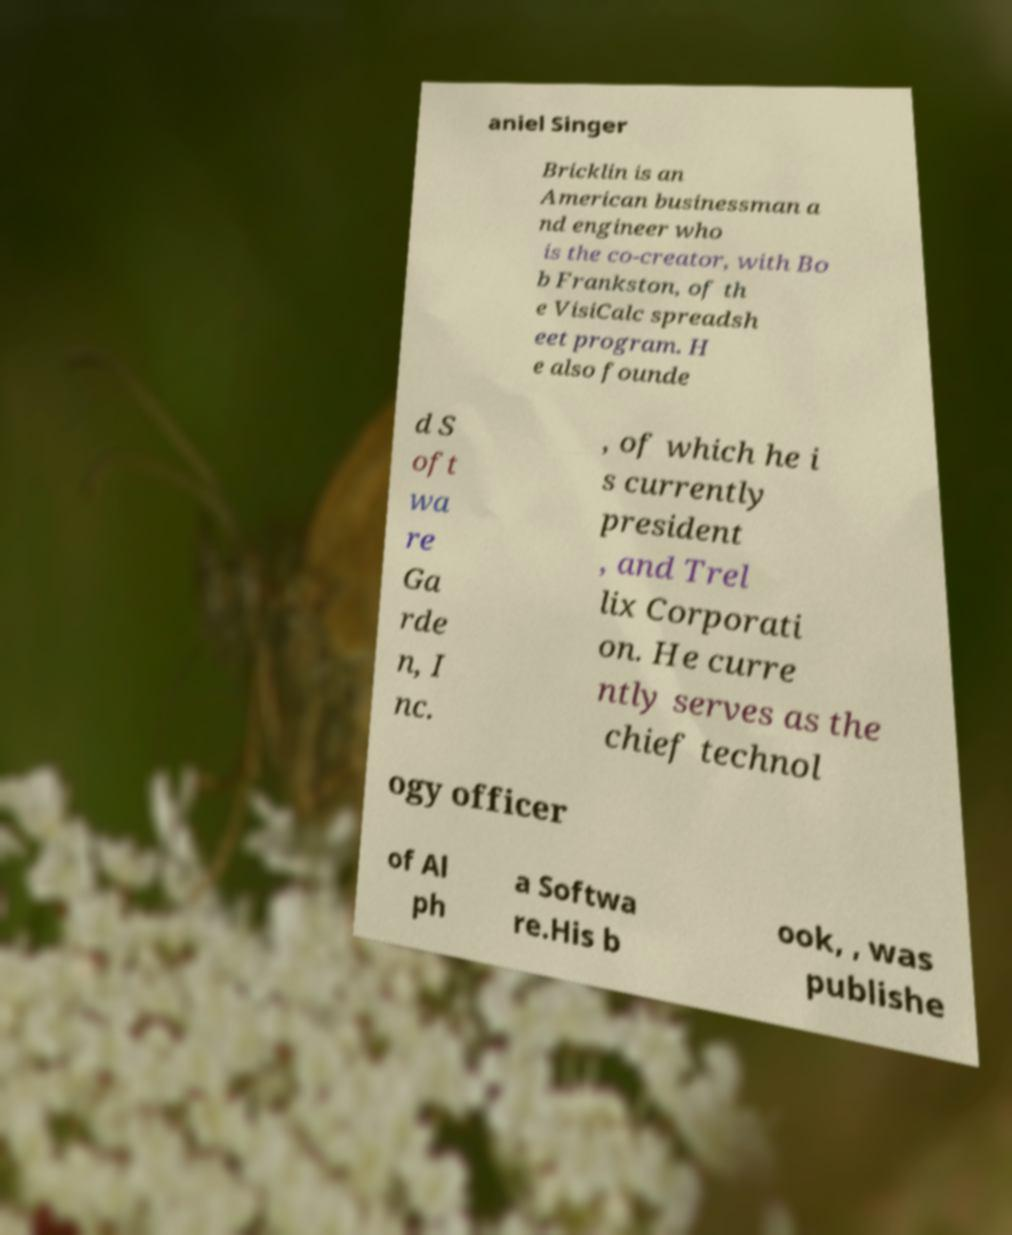I need the written content from this picture converted into text. Can you do that? aniel Singer Bricklin is an American businessman a nd engineer who is the co-creator, with Bo b Frankston, of th e VisiCalc spreadsh eet program. H e also founde d S oft wa re Ga rde n, I nc. , of which he i s currently president , and Trel lix Corporati on. He curre ntly serves as the chief technol ogy officer of Al ph a Softwa re.His b ook, , was publishe 